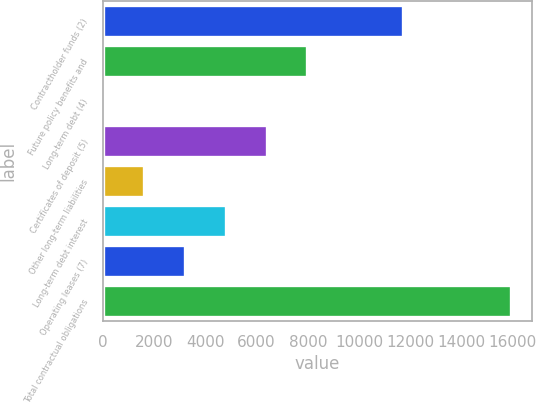<chart> <loc_0><loc_0><loc_500><loc_500><bar_chart><fcel>Contractholder funds (2)<fcel>Future policy benefits and<fcel>Long-term debt (4)<fcel>Certificates of deposit (5)<fcel>Other long-term liabilities<fcel>Long-term debt interest<fcel>Operating leases (7)<fcel>Total contractual obligations<nl><fcel>11733.2<fcel>7984.5<fcel>12.5<fcel>6390.1<fcel>1606.9<fcel>4795.7<fcel>3201.3<fcel>15956.5<nl></chart> 